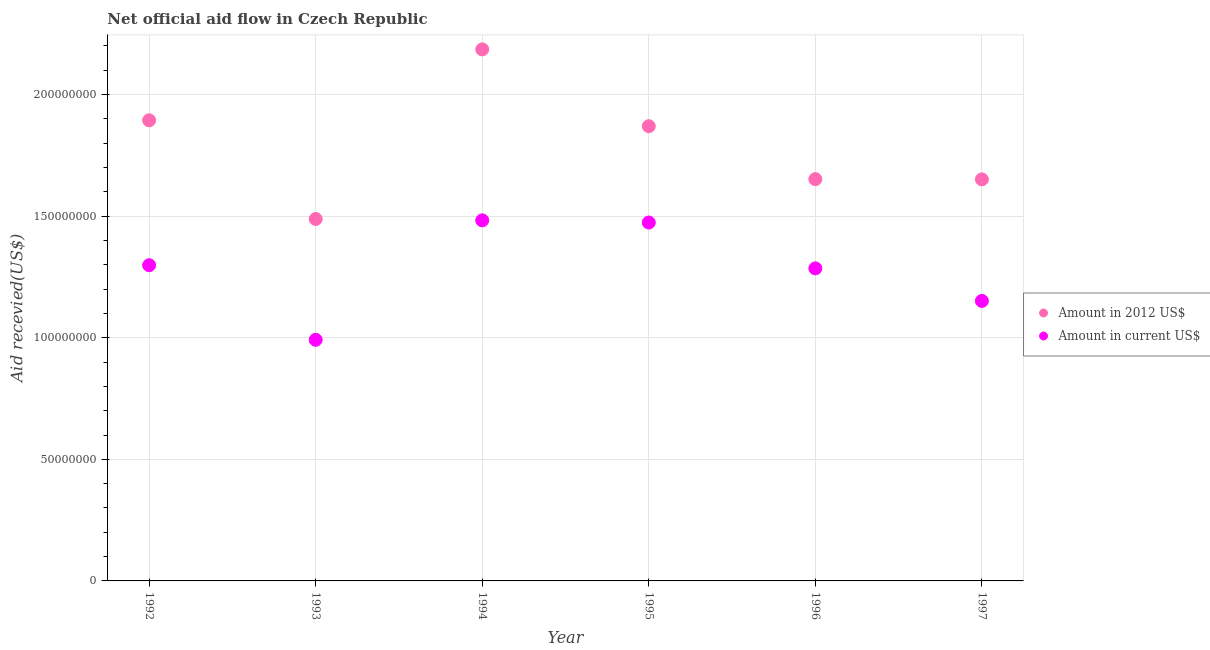How many different coloured dotlines are there?
Your answer should be very brief. 2. What is the amount of aid received(expressed in us$) in 1996?
Ensure brevity in your answer.  1.29e+08. Across all years, what is the maximum amount of aid received(expressed in 2012 us$)?
Your answer should be very brief. 2.19e+08. Across all years, what is the minimum amount of aid received(expressed in 2012 us$)?
Offer a very short reply. 1.49e+08. In which year was the amount of aid received(expressed in us$) maximum?
Make the answer very short. 1994. In which year was the amount of aid received(expressed in us$) minimum?
Your answer should be very brief. 1993. What is the total amount of aid received(expressed in us$) in the graph?
Provide a succinct answer. 7.68e+08. What is the difference between the amount of aid received(expressed in 2012 us$) in 1994 and that in 1996?
Keep it short and to the point. 5.34e+07. What is the difference between the amount of aid received(expressed in us$) in 1996 and the amount of aid received(expressed in 2012 us$) in 1992?
Provide a succinct answer. -6.09e+07. What is the average amount of aid received(expressed in us$) per year?
Offer a very short reply. 1.28e+08. In the year 1995, what is the difference between the amount of aid received(expressed in 2012 us$) and amount of aid received(expressed in us$)?
Keep it short and to the point. 3.96e+07. In how many years, is the amount of aid received(expressed in 2012 us$) greater than 90000000 US$?
Offer a very short reply. 6. What is the ratio of the amount of aid received(expressed in 2012 us$) in 1992 to that in 1997?
Make the answer very short. 1.15. Is the amount of aid received(expressed in us$) in 1993 less than that in 1997?
Provide a short and direct response. Yes. What is the difference between the highest and the second highest amount of aid received(expressed in us$)?
Offer a terse response. 8.90e+05. What is the difference between the highest and the lowest amount of aid received(expressed in 2012 us$)?
Keep it short and to the point. 6.97e+07. In how many years, is the amount of aid received(expressed in 2012 us$) greater than the average amount of aid received(expressed in 2012 us$) taken over all years?
Provide a succinct answer. 3. Is the sum of the amount of aid received(expressed in 2012 us$) in 1994 and 1995 greater than the maximum amount of aid received(expressed in us$) across all years?
Provide a short and direct response. Yes. Is the amount of aid received(expressed in us$) strictly greater than the amount of aid received(expressed in 2012 us$) over the years?
Provide a short and direct response. No. Is the amount of aid received(expressed in 2012 us$) strictly less than the amount of aid received(expressed in us$) over the years?
Keep it short and to the point. No. How many years are there in the graph?
Provide a short and direct response. 6. What is the difference between two consecutive major ticks on the Y-axis?
Provide a short and direct response. 5.00e+07. Does the graph contain grids?
Make the answer very short. Yes. Where does the legend appear in the graph?
Your answer should be compact. Center right. How many legend labels are there?
Offer a terse response. 2. How are the legend labels stacked?
Provide a succinct answer. Vertical. What is the title of the graph?
Provide a short and direct response. Net official aid flow in Czech Republic. Does "Technicians" appear as one of the legend labels in the graph?
Provide a short and direct response. No. What is the label or title of the X-axis?
Your answer should be very brief. Year. What is the label or title of the Y-axis?
Keep it short and to the point. Aid recevied(US$). What is the Aid recevied(US$) of Amount in 2012 US$ in 1992?
Give a very brief answer. 1.89e+08. What is the Aid recevied(US$) of Amount in current US$ in 1992?
Make the answer very short. 1.30e+08. What is the Aid recevied(US$) of Amount in 2012 US$ in 1993?
Offer a very short reply. 1.49e+08. What is the Aid recevied(US$) of Amount in current US$ in 1993?
Give a very brief answer. 9.92e+07. What is the Aid recevied(US$) of Amount in 2012 US$ in 1994?
Your response must be concise. 2.19e+08. What is the Aid recevied(US$) in Amount in current US$ in 1994?
Offer a terse response. 1.48e+08. What is the Aid recevied(US$) of Amount in 2012 US$ in 1995?
Your response must be concise. 1.87e+08. What is the Aid recevied(US$) of Amount in current US$ in 1995?
Offer a very short reply. 1.47e+08. What is the Aid recevied(US$) of Amount in 2012 US$ in 1996?
Keep it short and to the point. 1.65e+08. What is the Aid recevied(US$) of Amount in current US$ in 1996?
Your response must be concise. 1.29e+08. What is the Aid recevied(US$) of Amount in 2012 US$ in 1997?
Your answer should be compact. 1.65e+08. What is the Aid recevied(US$) in Amount in current US$ in 1997?
Offer a very short reply. 1.15e+08. Across all years, what is the maximum Aid recevied(US$) in Amount in 2012 US$?
Provide a short and direct response. 2.19e+08. Across all years, what is the maximum Aid recevied(US$) of Amount in current US$?
Give a very brief answer. 1.48e+08. Across all years, what is the minimum Aid recevied(US$) in Amount in 2012 US$?
Provide a short and direct response. 1.49e+08. Across all years, what is the minimum Aid recevied(US$) of Amount in current US$?
Provide a succinct answer. 9.92e+07. What is the total Aid recevied(US$) in Amount in 2012 US$ in the graph?
Your answer should be very brief. 1.07e+09. What is the total Aid recevied(US$) in Amount in current US$ in the graph?
Offer a very short reply. 7.68e+08. What is the difference between the Aid recevied(US$) in Amount in 2012 US$ in 1992 and that in 1993?
Provide a succinct answer. 4.06e+07. What is the difference between the Aid recevied(US$) of Amount in current US$ in 1992 and that in 1993?
Provide a succinct answer. 3.07e+07. What is the difference between the Aid recevied(US$) in Amount in 2012 US$ in 1992 and that in 1994?
Provide a succinct answer. -2.92e+07. What is the difference between the Aid recevied(US$) of Amount in current US$ in 1992 and that in 1994?
Offer a very short reply. -1.84e+07. What is the difference between the Aid recevied(US$) in Amount in 2012 US$ in 1992 and that in 1995?
Keep it short and to the point. 2.42e+06. What is the difference between the Aid recevied(US$) of Amount in current US$ in 1992 and that in 1995?
Give a very brief answer. -1.76e+07. What is the difference between the Aid recevied(US$) of Amount in 2012 US$ in 1992 and that in 1996?
Make the answer very short. 2.42e+07. What is the difference between the Aid recevied(US$) in Amount in current US$ in 1992 and that in 1996?
Your answer should be very brief. 1.29e+06. What is the difference between the Aid recevied(US$) in Amount in 2012 US$ in 1992 and that in 1997?
Your answer should be compact. 2.43e+07. What is the difference between the Aid recevied(US$) in Amount in current US$ in 1992 and that in 1997?
Offer a very short reply. 1.47e+07. What is the difference between the Aid recevied(US$) in Amount in 2012 US$ in 1993 and that in 1994?
Keep it short and to the point. -6.97e+07. What is the difference between the Aid recevied(US$) of Amount in current US$ in 1993 and that in 1994?
Keep it short and to the point. -4.91e+07. What is the difference between the Aid recevied(US$) in Amount in 2012 US$ in 1993 and that in 1995?
Ensure brevity in your answer.  -3.82e+07. What is the difference between the Aid recevied(US$) of Amount in current US$ in 1993 and that in 1995?
Give a very brief answer. -4.82e+07. What is the difference between the Aid recevied(US$) of Amount in 2012 US$ in 1993 and that in 1996?
Make the answer very short. -1.64e+07. What is the difference between the Aid recevied(US$) in Amount in current US$ in 1993 and that in 1996?
Keep it short and to the point. -2.94e+07. What is the difference between the Aid recevied(US$) of Amount in 2012 US$ in 1993 and that in 1997?
Offer a terse response. -1.63e+07. What is the difference between the Aid recevied(US$) in Amount in current US$ in 1993 and that in 1997?
Your answer should be compact. -1.60e+07. What is the difference between the Aid recevied(US$) in Amount in 2012 US$ in 1994 and that in 1995?
Provide a succinct answer. 3.16e+07. What is the difference between the Aid recevied(US$) in Amount in current US$ in 1994 and that in 1995?
Provide a succinct answer. 8.90e+05. What is the difference between the Aid recevied(US$) in Amount in 2012 US$ in 1994 and that in 1996?
Make the answer very short. 5.34e+07. What is the difference between the Aid recevied(US$) in Amount in current US$ in 1994 and that in 1996?
Keep it short and to the point. 1.97e+07. What is the difference between the Aid recevied(US$) of Amount in 2012 US$ in 1994 and that in 1997?
Your response must be concise. 5.34e+07. What is the difference between the Aid recevied(US$) in Amount in current US$ in 1994 and that in 1997?
Give a very brief answer. 3.31e+07. What is the difference between the Aid recevied(US$) of Amount in 2012 US$ in 1995 and that in 1996?
Your response must be concise. 2.18e+07. What is the difference between the Aid recevied(US$) in Amount in current US$ in 1995 and that in 1996?
Give a very brief answer. 1.88e+07. What is the difference between the Aid recevied(US$) of Amount in 2012 US$ in 1995 and that in 1997?
Your response must be concise. 2.19e+07. What is the difference between the Aid recevied(US$) of Amount in current US$ in 1995 and that in 1997?
Your answer should be very brief. 3.22e+07. What is the difference between the Aid recevied(US$) of Amount in current US$ in 1996 and that in 1997?
Your answer should be very brief. 1.34e+07. What is the difference between the Aid recevied(US$) in Amount in 2012 US$ in 1992 and the Aid recevied(US$) in Amount in current US$ in 1993?
Your answer should be very brief. 9.03e+07. What is the difference between the Aid recevied(US$) of Amount in 2012 US$ in 1992 and the Aid recevied(US$) of Amount in current US$ in 1994?
Provide a short and direct response. 4.11e+07. What is the difference between the Aid recevied(US$) in Amount in 2012 US$ in 1992 and the Aid recevied(US$) in Amount in current US$ in 1995?
Give a very brief answer. 4.20e+07. What is the difference between the Aid recevied(US$) in Amount in 2012 US$ in 1992 and the Aid recevied(US$) in Amount in current US$ in 1996?
Your answer should be very brief. 6.09e+07. What is the difference between the Aid recevied(US$) of Amount in 2012 US$ in 1992 and the Aid recevied(US$) of Amount in current US$ in 1997?
Your answer should be compact. 7.43e+07. What is the difference between the Aid recevied(US$) in Amount in 2012 US$ in 1993 and the Aid recevied(US$) in Amount in current US$ in 1994?
Give a very brief answer. 5.60e+05. What is the difference between the Aid recevied(US$) in Amount in 2012 US$ in 1993 and the Aid recevied(US$) in Amount in current US$ in 1995?
Offer a terse response. 1.45e+06. What is the difference between the Aid recevied(US$) in Amount in 2012 US$ in 1993 and the Aid recevied(US$) in Amount in current US$ in 1996?
Ensure brevity in your answer.  2.03e+07. What is the difference between the Aid recevied(US$) of Amount in 2012 US$ in 1993 and the Aid recevied(US$) of Amount in current US$ in 1997?
Make the answer very short. 3.37e+07. What is the difference between the Aid recevied(US$) in Amount in 2012 US$ in 1994 and the Aid recevied(US$) in Amount in current US$ in 1995?
Provide a short and direct response. 7.12e+07. What is the difference between the Aid recevied(US$) in Amount in 2012 US$ in 1994 and the Aid recevied(US$) in Amount in current US$ in 1996?
Your answer should be very brief. 9.00e+07. What is the difference between the Aid recevied(US$) in Amount in 2012 US$ in 1994 and the Aid recevied(US$) in Amount in current US$ in 1997?
Provide a succinct answer. 1.03e+08. What is the difference between the Aid recevied(US$) of Amount in 2012 US$ in 1995 and the Aid recevied(US$) of Amount in current US$ in 1996?
Offer a terse response. 5.85e+07. What is the difference between the Aid recevied(US$) of Amount in 2012 US$ in 1995 and the Aid recevied(US$) of Amount in current US$ in 1997?
Provide a succinct answer. 7.18e+07. What is the difference between the Aid recevied(US$) of Amount in 2012 US$ in 1996 and the Aid recevied(US$) of Amount in current US$ in 1997?
Ensure brevity in your answer.  5.01e+07. What is the average Aid recevied(US$) in Amount in 2012 US$ per year?
Offer a terse response. 1.79e+08. What is the average Aid recevied(US$) in Amount in current US$ per year?
Your response must be concise. 1.28e+08. In the year 1992, what is the difference between the Aid recevied(US$) in Amount in 2012 US$ and Aid recevied(US$) in Amount in current US$?
Ensure brevity in your answer.  5.96e+07. In the year 1993, what is the difference between the Aid recevied(US$) of Amount in 2012 US$ and Aid recevied(US$) of Amount in current US$?
Your response must be concise. 4.97e+07. In the year 1994, what is the difference between the Aid recevied(US$) in Amount in 2012 US$ and Aid recevied(US$) in Amount in current US$?
Ensure brevity in your answer.  7.03e+07. In the year 1995, what is the difference between the Aid recevied(US$) of Amount in 2012 US$ and Aid recevied(US$) of Amount in current US$?
Give a very brief answer. 3.96e+07. In the year 1996, what is the difference between the Aid recevied(US$) in Amount in 2012 US$ and Aid recevied(US$) in Amount in current US$?
Offer a terse response. 3.67e+07. In the year 1997, what is the difference between the Aid recevied(US$) of Amount in 2012 US$ and Aid recevied(US$) of Amount in current US$?
Provide a succinct answer. 5.00e+07. What is the ratio of the Aid recevied(US$) of Amount in 2012 US$ in 1992 to that in 1993?
Provide a succinct answer. 1.27. What is the ratio of the Aid recevied(US$) of Amount in current US$ in 1992 to that in 1993?
Give a very brief answer. 1.31. What is the ratio of the Aid recevied(US$) in Amount in 2012 US$ in 1992 to that in 1994?
Your answer should be very brief. 0.87. What is the ratio of the Aid recevied(US$) of Amount in current US$ in 1992 to that in 1994?
Your answer should be compact. 0.88. What is the ratio of the Aid recevied(US$) of Amount in 2012 US$ in 1992 to that in 1995?
Keep it short and to the point. 1.01. What is the ratio of the Aid recevied(US$) of Amount in current US$ in 1992 to that in 1995?
Your answer should be very brief. 0.88. What is the ratio of the Aid recevied(US$) in Amount in 2012 US$ in 1992 to that in 1996?
Ensure brevity in your answer.  1.15. What is the ratio of the Aid recevied(US$) in Amount in 2012 US$ in 1992 to that in 1997?
Offer a very short reply. 1.15. What is the ratio of the Aid recevied(US$) in Amount in current US$ in 1992 to that in 1997?
Offer a terse response. 1.13. What is the ratio of the Aid recevied(US$) in Amount in 2012 US$ in 1993 to that in 1994?
Your answer should be compact. 0.68. What is the ratio of the Aid recevied(US$) in Amount in current US$ in 1993 to that in 1994?
Your response must be concise. 0.67. What is the ratio of the Aid recevied(US$) of Amount in 2012 US$ in 1993 to that in 1995?
Your response must be concise. 0.8. What is the ratio of the Aid recevied(US$) of Amount in current US$ in 1993 to that in 1995?
Give a very brief answer. 0.67. What is the ratio of the Aid recevied(US$) of Amount in 2012 US$ in 1993 to that in 1996?
Keep it short and to the point. 0.9. What is the ratio of the Aid recevied(US$) of Amount in current US$ in 1993 to that in 1996?
Your response must be concise. 0.77. What is the ratio of the Aid recevied(US$) in Amount in 2012 US$ in 1993 to that in 1997?
Ensure brevity in your answer.  0.9. What is the ratio of the Aid recevied(US$) of Amount in current US$ in 1993 to that in 1997?
Your answer should be very brief. 0.86. What is the ratio of the Aid recevied(US$) in Amount in 2012 US$ in 1994 to that in 1995?
Offer a very short reply. 1.17. What is the ratio of the Aid recevied(US$) of Amount in current US$ in 1994 to that in 1995?
Your answer should be very brief. 1.01. What is the ratio of the Aid recevied(US$) in Amount in 2012 US$ in 1994 to that in 1996?
Ensure brevity in your answer.  1.32. What is the ratio of the Aid recevied(US$) of Amount in current US$ in 1994 to that in 1996?
Provide a succinct answer. 1.15. What is the ratio of the Aid recevied(US$) of Amount in 2012 US$ in 1994 to that in 1997?
Make the answer very short. 1.32. What is the ratio of the Aid recevied(US$) of Amount in current US$ in 1994 to that in 1997?
Keep it short and to the point. 1.29. What is the ratio of the Aid recevied(US$) of Amount in 2012 US$ in 1995 to that in 1996?
Provide a succinct answer. 1.13. What is the ratio of the Aid recevied(US$) of Amount in current US$ in 1995 to that in 1996?
Your answer should be very brief. 1.15. What is the ratio of the Aid recevied(US$) of Amount in 2012 US$ in 1995 to that in 1997?
Ensure brevity in your answer.  1.13. What is the ratio of the Aid recevied(US$) in Amount in current US$ in 1995 to that in 1997?
Your response must be concise. 1.28. What is the ratio of the Aid recevied(US$) of Amount in 2012 US$ in 1996 to that in 1997?
Provide a succinct answer. 1. What is the ratio of the Aid recevied(US$) of Amount in current US$ in 1996 to that in 1997?
Ensure brevity in your answer.  1.12. What is the difference between the highest and the second highest Aid recevied(US$) of Amount in 2012 US$?
Your answer should be compact. 2.92e+07. What is the difference between the highest and the second highest Aid recevied(US$) of Amount in current US$?
Offer a very short reply. 8.90e+05. What is the difference between the highest and the lowest Aid recevied(US$) of Amount in 2012 US$?
Give a very brief answer. 6.97e+07. What is the difference between the highest and the lowest Aid recevied(US$) of Amount in current US$?
Give a very brief answer. 4.91e+07. 